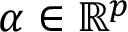<formula> <loc_0><loc_0><loc_500><loc_500>\alpha \in \mathbb { R } ^ { p }</formula> 